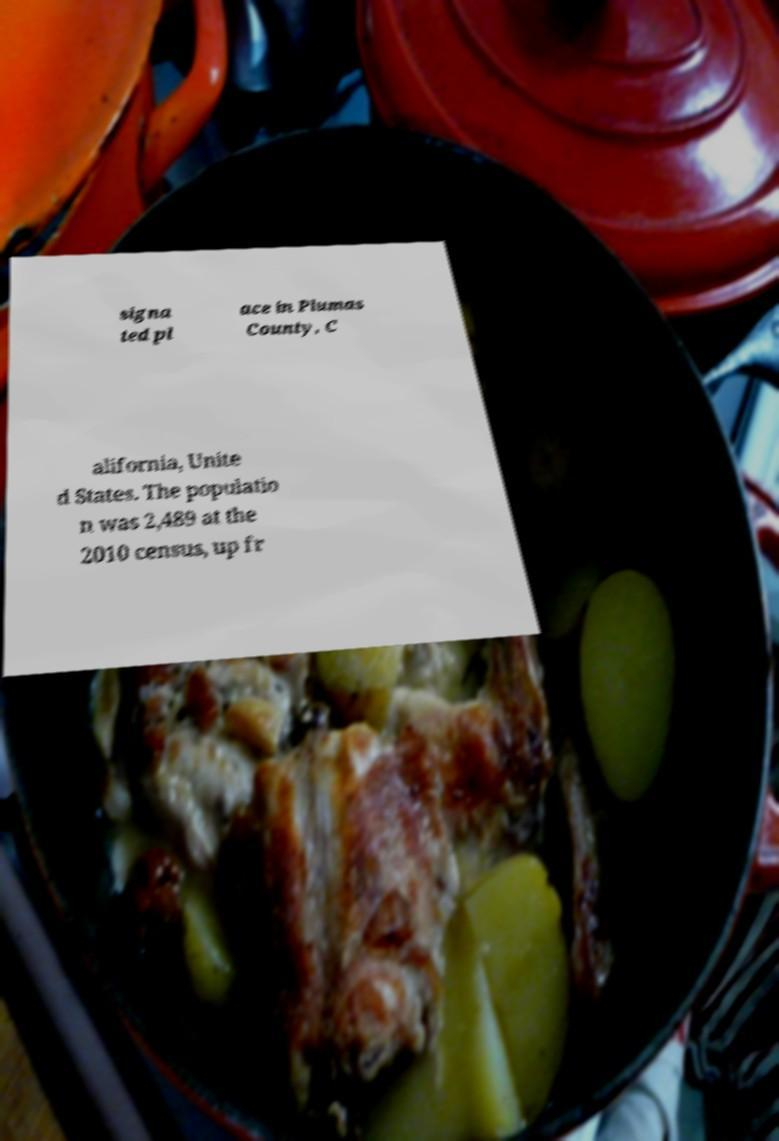Please read and relay the text visible in this image. What does it say? signa ted pl ace in Plumas County, C alifornia, Unite d States. The populatio n was 2,489 at the 2010 census, up fr 